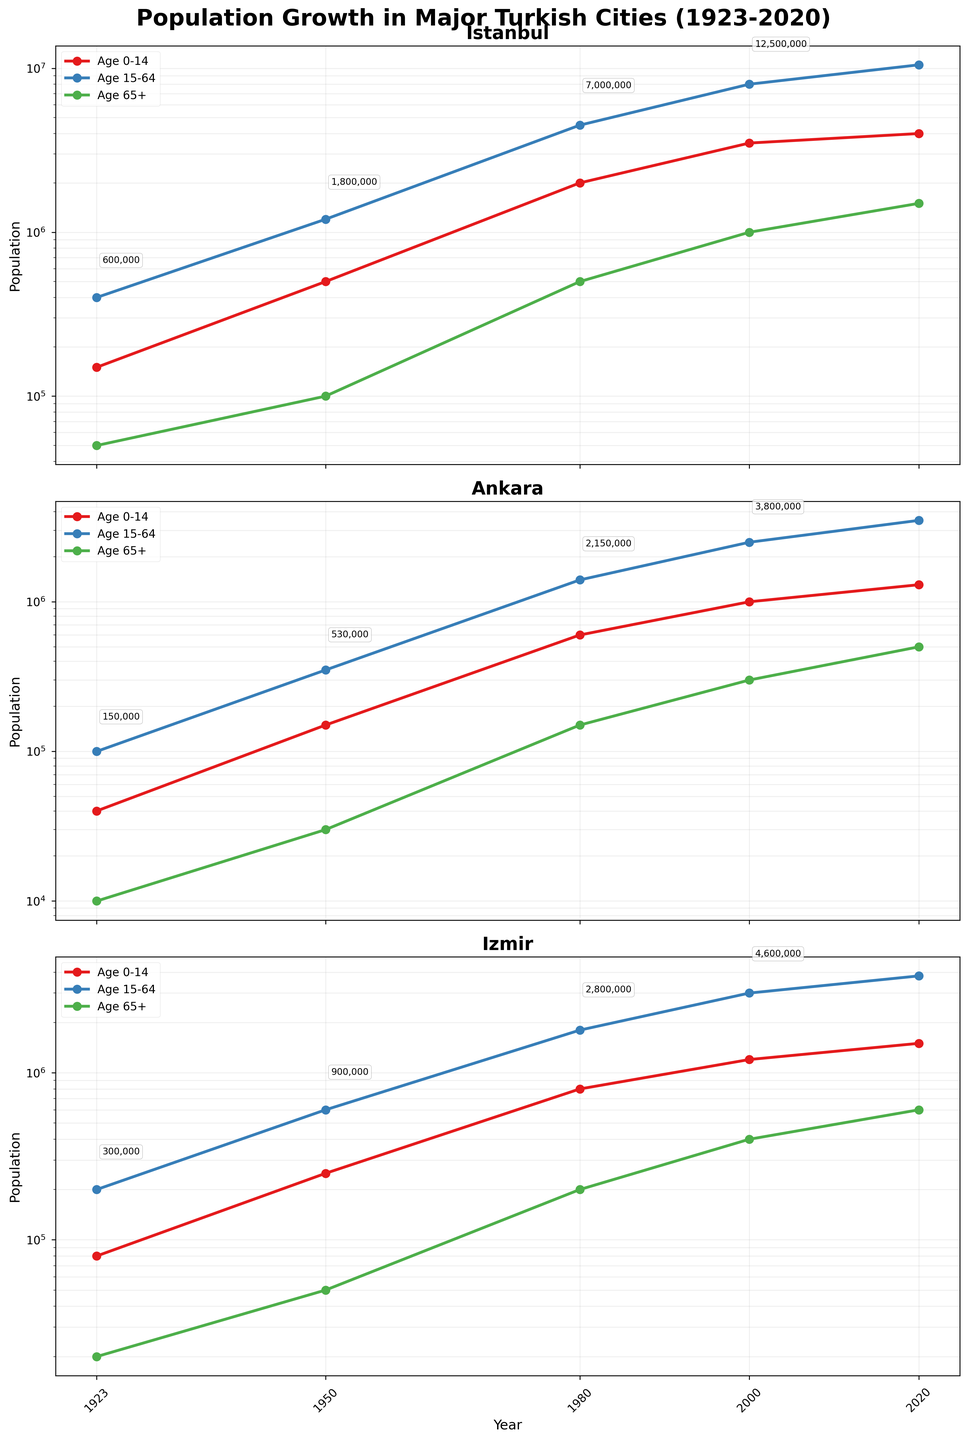What is the title of the chart? The title is located at the top of the figure and indicates the subject of the visualization. In this case, it reads "Population Growth in Major Turkish Cities (1923-2020)".
Answer: Population Growth in Major Turkish Cities (1923-2020) Which city had the highest population of the age group 15-64 in the year 2020? Locate the subplot for 2020 in the figure and compare the population of the age group 15-64 among Istanbul, Ankara, and Izmir. Istanbul has the highest population for that age group.
Answer: Istanbul How has the population of the age group 0-14 in Ankara changed from 1923 to 2020? Observe the subplot for Ankara and look at the population numbers for the age group 0-14 in 1923 and 2020. It increased from 40,000 in 1923 to 1,300,000 in 2020.
Answer: Increased from 40,000 to 1,300,000 Which age group saw the largest population increase in Izmir from 1950 to 1980? Compare the differences in population among the age groups (0-14, 15-64, and 65+) in Izmir by examining the subplot for Izmir in 1950 and 1980. The Age 15-64 group saw the largest increase, from 600,000 in 1950 to 1,800,000 in 1980.
Answer: Age 15-64 In which city did the age group 65+ have the steepest growth curve between 2000 and 2020? Look at the lines representing the age group 65+ in each subplot and focus on the slope difference between 2000 and 2020. Ankara has the steepest growth curve.
Answer: Ankara Comparing the year 1980, which city had the largest total population? Examine the total population annotations for each city in 1980. Istanbul had the largest total population.
Answer: Istanbul How do the populations of age group 0-14 in 1923 and 2020 compare across all three cities? Locate the data points for the age group 0-14 in 1923 and 2020 for Istanbul, Ankara, and Izmir. Compare the values for both years. All three cities saw significant increases.
Answer: All increased What is the general trend of the population aged 65+ in Istanbul from 1923 to 2020? Observe the line for the age group 65+ in the Istanbul subplot across the years. The population shows a steadily increasing trend.
Answer: Steadily increasing Which city had the smallest population for the age group 0-14 in 1923? Look at the subplot for 1923 and compare the population of the age group 0-14 among Istanbul, Ankara, and Izmir. Ankara had the smallest population.
Answer: Ankara 